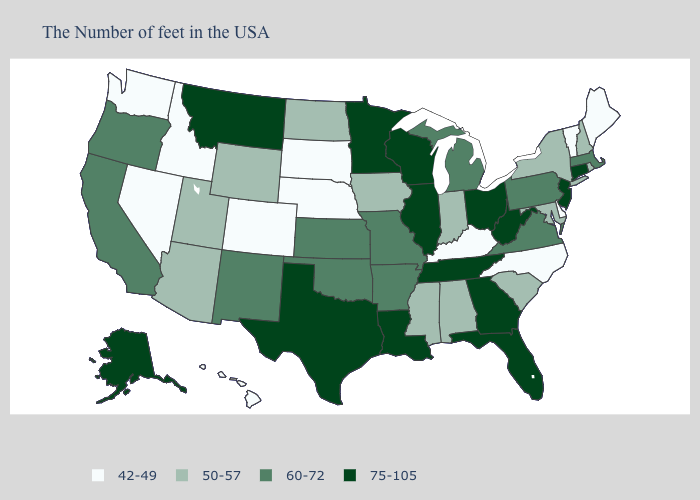What is the value of North Dakota?
Give a very brief answer. 50-57. Name the states that have a value in the range 60-72?
Short answer required. Massachusetts, Pennsylvania, Virginia, Michigan, Missouri, Arkansas, Kansas, Oklahoma, New Mexico, California, Oregon. Name the states that have a value in the range 75-105?
Quick response, please. Connecticut, New Jersey, West Virginia, Ohio, Florida, Georgia, Tennessee, Wisconsin, Illinois, Louisiana, Minnesota, Texas, Montana, Alaska. Does the map have missing data?
Write a very short answer. No. What is the value of Oklahoma?
Give a very brief answer. 60-72. Name the states that have a value in the range 75-105?
Quick response, please. Connecticut, New Jersey, West Virginia, Ohio, Florida, Georgia, Tennessee, Wisconsin, Illinois, Louisiana, Minnesota, Texas, Montana, Alaska. Name the states that have a value in the range 75-105?
Short answer required. Connecticut, New Jersey, West Virginia, Ohio, Florida, Georgia, Tennessee, Wisconsin, Illinois, Louisiana, Minnesota, Texas, Montana, Alaska. Name the states that have a value in the range 60-72?
Be succinct. Massachusetts, Pennsylvania, Virginia, Michigan, Missouri, Arkansas, Kansas, Oklahoma, New Mexico, California, Oregon. Does the first symbol in the legend represent the smallest category?
Short answer required. Yes. What is the value of Florida?
Give a very brief answer. 75-105. What is the value of Missouri?
Quick response, please. 60-72. Name the states that have a value in the range 75-105?
Short answer required. Connecticut, New Jersey, West Virginia, Ohio, Florida, Georgia, Tennessee, Wisconsin, Illinois, Louisiana, Minnesota, Texas, Montana, Alaska. Name the states that have a value in the range 60-72?
Keep it brief. Massachusetts, Pennsylvania, Virginia, Michigan, Missouri, Arkansas, Kansas, Oklahoma, New Mexico, California, Oregon. Does North Dakota have the highest value in the USA?
Concise answer only. No. Name the states that have a value in the range 60-72?
Short answer required. Massachusetts, Pennsylvania, Virginia, Michigan, Missouri, Arkansas, Kansas, Oklahoma, New Mexico, California, Oregon. 